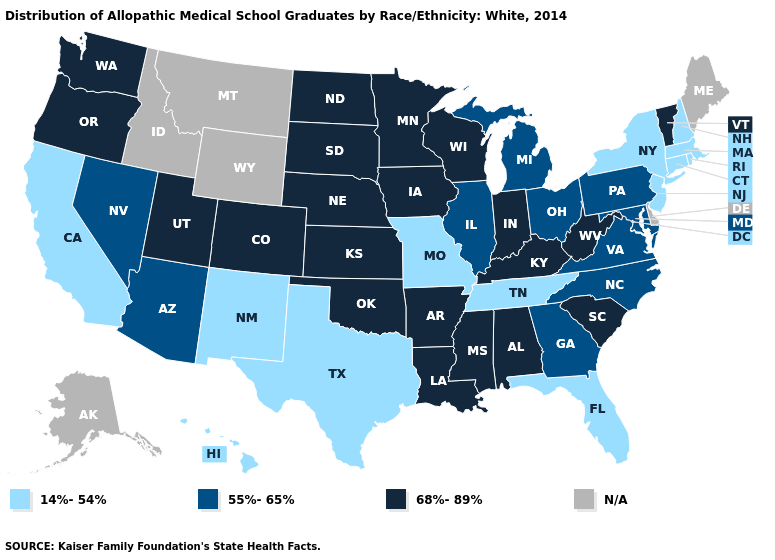What is the value of Wyoming?
Keep it brief. N/A. How many symbols are there in the legend?
Answer briefly. 4. What is the lowest value in the MidWest?
Write a very short answer. 14%-54%. Does the first symbol in the legend represent the smallest category?
Answer briefly. Yes. Which states hav the highest value in the Northeast?
Write a very short answer. Vermont. What is the value of Oklahoma?
Concise answer only. 68%-89%. Name the states that have a value in the range 14%-54%?
Short answer required. California, Connecticut, Florida, Hawaii, Massachusetts, Missouri, New Hampshire, New Jersey, New Mexico, New York, Rhode Island, Tennessee, Texas. Which states have the highest value in the USA?
Answer briefly. Alabama, Arkansas, Colorado, Indiana, Iowa, Kansas, Kentucky, Louisiana, Minnesota, Mississippi, Nebraska, North Dakota, Oklahoma, Oregon, South Carolina, South Dakota, Utah, Vermont, Washington, West Virginia, Wisconsin. What is the value of Utah?
Be succinct. 68%-89%. Among the states that border North Carolina , which have the highest value?
Answer briefly. South Carolina. What is the lowest value in the South?
Quick response, please. 14%-54%. How many symbols are there in the legend?
Answer briefly. 4. Name the states that have a value in the range 14%-54%?
Answer briefly. California, Connecticut, Florida, Hawaii, Massachusetts, Missouri, New Hampshire, New Jersey, New Mexico, New York, Rhode Island, Tennessee, Texas. 